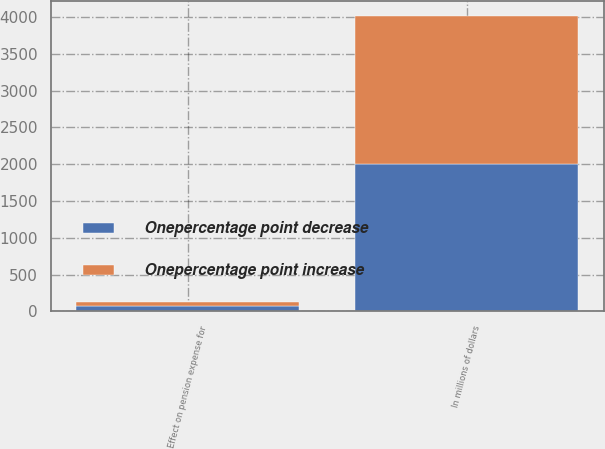Convert chart. <chart><loc_0><loc_0><loc_500><loc_500><stacked_bar_chart><ecel><fcel>In millions of dollars<fcel>Effect on pension expense for<nl><fcel>Onepercentage point decrease<fcel>2008<fcel>66<nl><fcel>Onepercentage point increase<fcel>2008<fcel>66<nl></chart> 